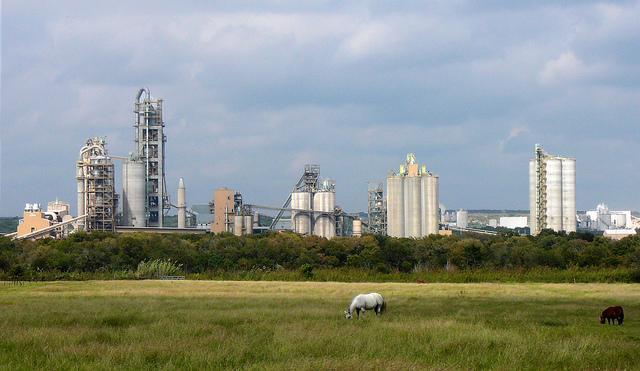How many sandwiches are pictured?
Give a very brief answer. 0. 